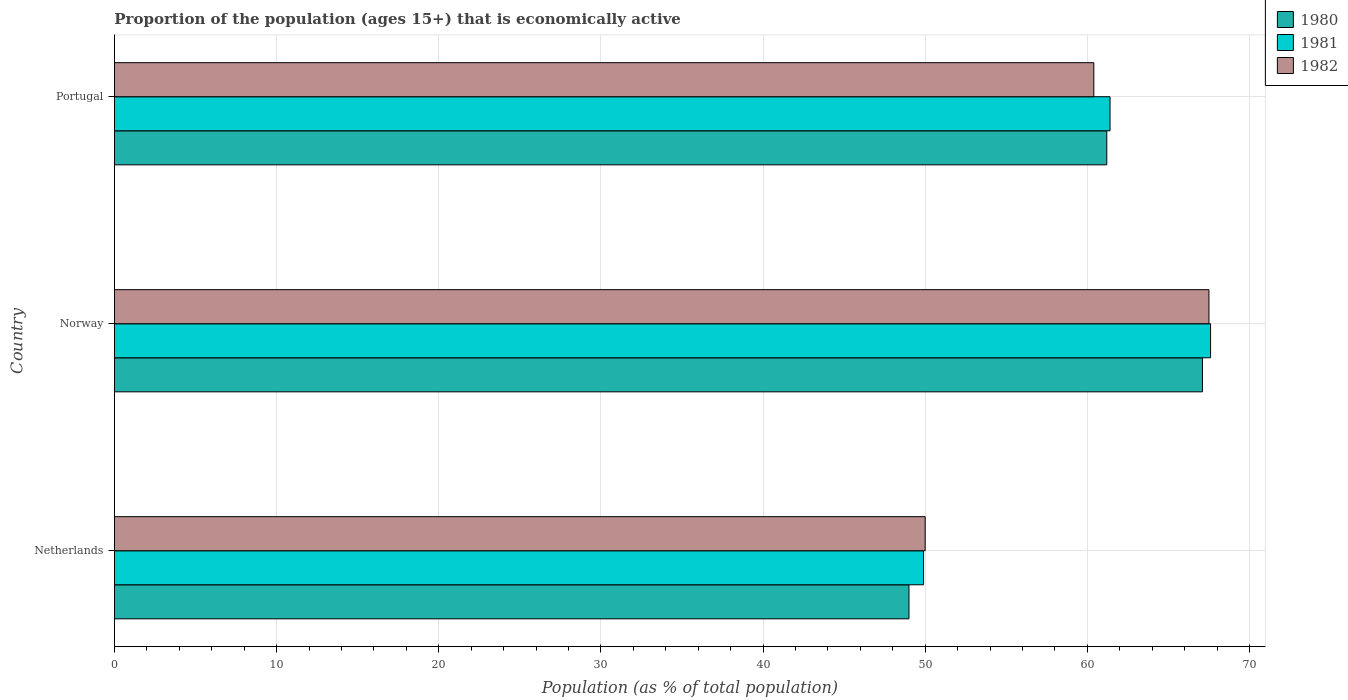How many groups of bars are there?
Ensure brevity in your answer.  3. Are the number of bars on each tick of the Y-axis equal?
Your response must be concise. Yes. How many bars are there on the 1st tick from the top?
Your answer should be very brief. 3. What is the label of the 3rd group of bars from the top?
Make the answer very short. Netherlands. What is the proportion of the population that is economically active in 1981 in Netherlands?
Keep it short and to the point. 49.9. Across all countries, what is the maximum proportion of the population that is economically active in 1982?
Keep it short and to the point. 67.5. Across all countries, what is the minimum proportion of the population that is economically active in 1981?
Your response must be concise. 49.9. In which country was the proportion of the population that is economically active in 1980 maximum?
Your response must be concise. Norway. In which country was the proportion of the population that is economically active in 1981 minimum?
Make the answer very short. Netherlands. What is the total proportion of the population that is economically active in 1981 in the graph?
Offer a terse response. 178.9. What is the difference between the proportion of the population that is economically active in 1980 in Norway and that in Portugal?
Make the answer very short. 5.9. What is the difference between the proportion of the population that is economically active in 1980 in Norway and the proportion of the population that is economically active in 1982 in Portugal?
Offer a terse response. 6.7. What is the average proportion of the population that is economically active in 1982 per country?
Ensure brevity in your answer.  59.3. What is the difference between the proportion of the population that is economically active in 1982 and proportion of the population that is economically active in 1980 in Portugal?
Keep it short and to the point. -0.8. What is the ratio of the proportion of the population that is economically active in 1982 in Netherlands to that in Portugal?
Give a very brief answer. 0.83. What is the difference between the highest and the second highest proportion of the population that is economically active in 1981?
Your answer should be compact. 6.2. What is the difference between the highest and the lowest proportion of the population that is economically active in 1980?
Offer a very short reply. 18.1. In how many countries, is the proportion of the population that is economically active in 1980 greater than the average proportion of the population that is economically active in 1980 taken over all countries?
Your answer should be compact. 2. What does the 2nd bar from the top in Netherlands represents?
Give a very brief answer. 1981. What does the 3rd bar from the bottom in Netherlands represents?
Keep it short and to the point. 1982. Is it the case that in every country, the sum of the proportion of the population that is economically active in 1981 and proportion of the population that is economically active in 1982 is greater than the proportion of the population that is economically active in 1980?
Give a very brief answer. Yes. What is the difference between two consecutive major ticks on the X-axis?
Your answer should be compact. 10. Are the values on the major ticks of X-axis written in scientific E-notation?
Your answer should be compact. No. Does the graph contain grids?
Give a very brief answer. Yes. How many legend labels are there?
Give a very brief answer. 3. What is the title of the graph?
Keep it short and to the point. Proportion of the population (ages 15+) that is economically active. Does "2007" appear as one of the legend labels in the graph?
Offer a very short reply. No. What is the label or title of the X-axis?
Make the answer very short. Population (as % of total population). What is the label or title of the Y-axis?
Keep it short and to the point. Country. What is the Population (as % of total population) in 1981 in Netherlands?
Ensure brevity in your answer.  49.9. What is the Population (as % of total population) of 1980 in Norway?
Your answer should be compact. 67.1. What is the Population (as % of total population) in 1981 in Norway?
Offer a terse response. 67.6. What is the Population (as % of total population) in 1982 in Norway?
Offer a very short reply. 67.5. What is the Population (as % of total population) of 1980 in Portugal?
Provide a succinct answer. 61.2. What is the Population (as % of total population) in 1981 in Portugal?
Provide a short and direct response. 61.4. What is the Population (as % of total population) of 1982 in Portugal?
Your answer should be compact. 60.4. Across all countries, what is the maximum Population (as % of total population) of 1980?
Provide a succinct answer. 67.1. Across all countries, what is the maximum Population (as % of total population) in 1981?
Your answer should be very brief. 67.6. Across all countries, what is the maximum Population (as % of total population) in 1982?
Offer a terse response. 67.5. Across all countries, what is the minimum Population (as % of total population) of 1980?
Make the answer very short. 49. Across all countries, what is the minimum Population (as % of total population) in 1981?
Your response must be concise. 49.9. Across all countries, what is the minimum Population (as % of total population) of 1982?
Offer a terse response. 50. What is the total Population (as % of total population) of 1980 in the graph?
Keep it short and to the point. 177.3. What is the total Population (as % of total population) in 1981 in the graph?
Your answer should be very brief. 178.9. What is the total Population (as % of total population) of 1982 in the graph?
Your answer should be compact. 177.9. What is the difference between the Population (as % of total population) in 1980 in Netherlands and that in Norway?
Your answer should be compact. -18.1. What is the difference between the Population (as % of total population) of 1981 in Netherlands and that in Norway?
Your response must be concise. -17.7. What is the difference between the Population (as % of total population) of 1982 in Netherlands and that in Norway?
Your answer should be compact. -17.5. What is the difference between the Population (as % of total population) in 1980 in Netherlands and that in Portugal?
Make the answer very short. -12.2. What is the difference between the Population (as % of total population) in 1981 in Netherlands and that in Portugal?
Offer a terse response. -11.5. What is the difference between the Population (as % of total population) of 1982 in Netherlands and that in Portugal?
Provide a short and direct response. -10.4. What is the difference between the Population (as % of total population) of 1980 in Norway and that in Portugal?
Offer a very short reply. 5.9. What is the difference between the Population (as % of total population) of 1981 in Norway and that in Portugal?
Give a very brief answer. 6.2. What is the difference between the Population (as % of total population) of 1982 in Norway and that in Portugal?
Give a very brief answer. 7.1. What is the difference between the Population (as % of total population) in 1980 in Netherlands and the Population (as % of total population) in 1981 in Norway?
Your answer should be very brief. -18.6. What is the difference between the Population (as % of total population) in 1980 in Netherlands and the Population (as % of total population) in 1982 in Norway?
Give a very brief answer. -18.5. What is the difference between the Population (as % of total population) in 1981 in Netherlands and the Population (as % of total population) in 1982 in Norway?
Provide a short and direct response. -17.6. What is the difference between the Population (as % of total population) in 1980 in Netherlands and the Population (as % of total population) in 1981 in Portugal?
Offer a terse response. -12.4. What is the difference between the Population (as % of total population) of 1981 in Netherlands and the Population (as % of total population) of 1982 in Portugal?
Give a very brief answer. -10.5. What is the difference between the Population (as % of total population) in 1981 in Norway and the Population (as % of total population) in 1982 in Portugal?
Give a very brief answer. 7.2. What is the average Population (as % of total population) of 1980 per country?
Ensure brevity in your answer.  59.1. What is the average Population (as % of total population) in 1981 per country?
Give a very brief answer. 59.63. What is the average Population (as % of total population) of 1982 per country?
Offer a very short reply. 59.3. What is the difference between the Population (as % of total population) of 1980 and Population (as % of total population) of 1981 in Netherlands?
Keep it short and to the point. -0.9. What is the difference between the Population (as % of total population) of 1981 and Population (as % of total population) of 1982 in Netherlands?
Your answer should be very brief. -0.1. What is the difference between the Population (as % of total population) in 1980 and Population (as % of total population) in 1981 in Norway?
Your response must be concise. -0.5. What is the difference between the Population (as % of total population) in 1980 and Population (as % of total population) in 1982 in Norway?
Ensure brevity in your answer.  -0.4. What is the difference between the Population (as % of total population) of 1980 and Population (as % of total population) of 1981 in Portugal?
Ensure brevity in your answer.  -0.2. What is the difference between the Population (as % of total population) of 1980 and Population (as % of total population) of 1982 in Portugal?
Make the answer very short. 0.8. What is the ratio of the Population (as % of total population) in 1980 in Netherlands to that in Norway?
Provide a short and direct response. 0.73. What is the ratio of the Population (as % of total population) of 1981 in Netherlands to that in Norway?
Make the answer very short. 0.74. What is the ratio of the Population (as % of total population) in 1982 in Netherlands to that in Norway?
Offer a very short reply. 0.74. What is the ratio of the Population (as % of total population) of 1980 in Netherlands to that in Portugal?
Provide a short and direct response. 0.8. What is the ratio of the Population (as % of total population) in 1981 in Netherlands to that in Portugal?
Offer a very short reply. 0.81. What is the ratio of the Population (as % of total population) of 1982 in Netherlands to that in Portugal?
Provide a succinct answer. 0.83. What is the ratio of the Population (as % of total population) in 1980 in Norway to that in Portugal?
Provide a short and direct response. 1.1. What is the ratio of the Population (as % of total population) of 1981 in Norway to that in Portugal?
Provide a short and direct response. 1.1. What is the ratio of the Population (as % of total population) in 1982 in Norway to that in Portugal?
Keep it short and to the point. 1.12. What is the difference between the highest and the second highest Population (as % of total population) of 1982?
Keep it short and to the point. 7.1. What is the difference between the highest and the lowest Population (as % of total population) in 1980?
Provide a short and direct response. 18.1. What is the difference between the highest and the lowest Population (as % of total population) of 1981?
Keep it short and to the point. 17.7. What is the difference between the highest and the lowest Population (as % of total population) in 1982?
Ensure brevity in your answer.  17.5. 